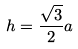Convert formula to latex. <formula><loc_0><loc_0><loc_500><loc_500>h = \frac { \sqrt { 3 } } { 2 } a</formula> 